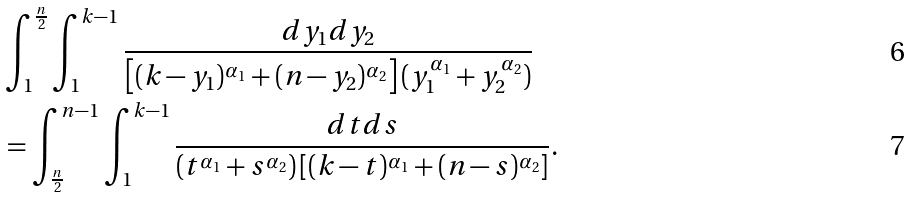Convert formula to latex. <formula><loc_0><loc_0><loc_500><loc_500>& \int _ { 1 } ^ { \frac { n } { 2 } } \int _ { 1 } ^ { k - 1 } \frac { d y _ { 1 } d y _ { 2 } } { \left [ ( k - y _ { 1 } ) ^ { \alpha _ { 1 } } + ( n - y _ { 2 } ) ^ { \alpha _ { 2 } } \right ] ( y _ { 1 } ^ { \alpha _ { 1 } } + y _ { 2 } ^ { \alpha _ { 2 } } ) } \\ & = \int _ { \frac { n } { 2 } } ^ { n - 1 } \int _ { 1 } ^ { k - 1 } \frac { d t d s } { ( t ^ { \alpha _ { 1 } } + s ^ { \alpha _ { 2 } } ) \left [ ( k - t ) ^ { \alpha _ { 1 } } + ( n - s ) ^ { \alpha _ { 2 } } \right ] } .</formula> 